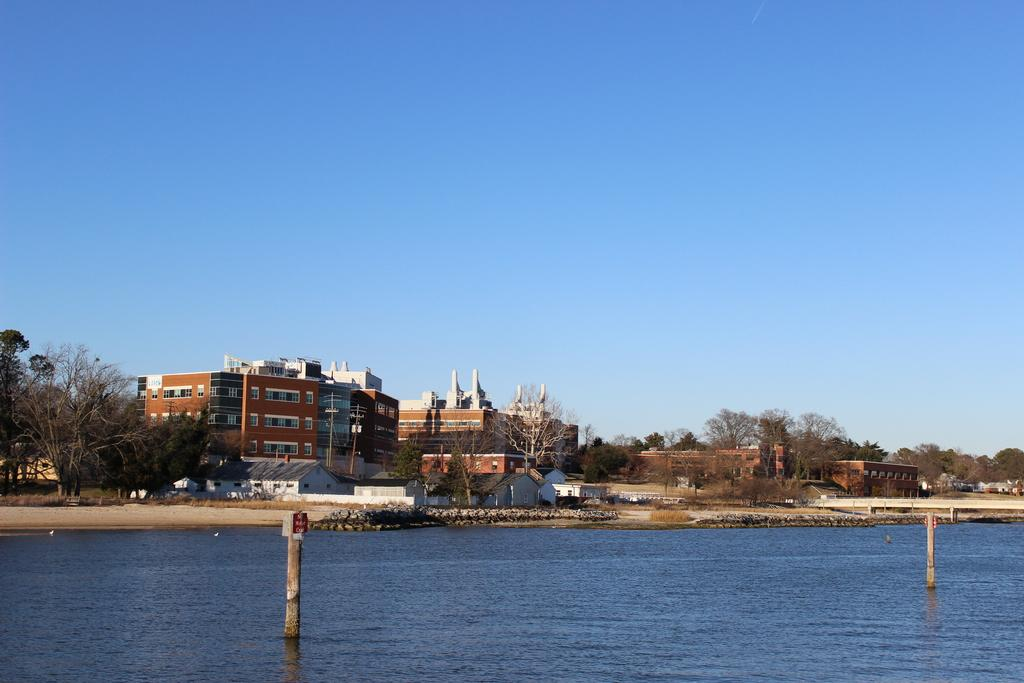What type of natural feature is present in the image? There is a river in the image. What other elements can be seen in the image? There are trees and buildings in the image. What is visible in the sky in the image? The sky is clear and visible in the image. How many girls are sitting with the grandfather in the image? There is no grandfather or girls present in the image. What is the amount of water in the river in the image? The image does not provide information about the amount of water in the river. 